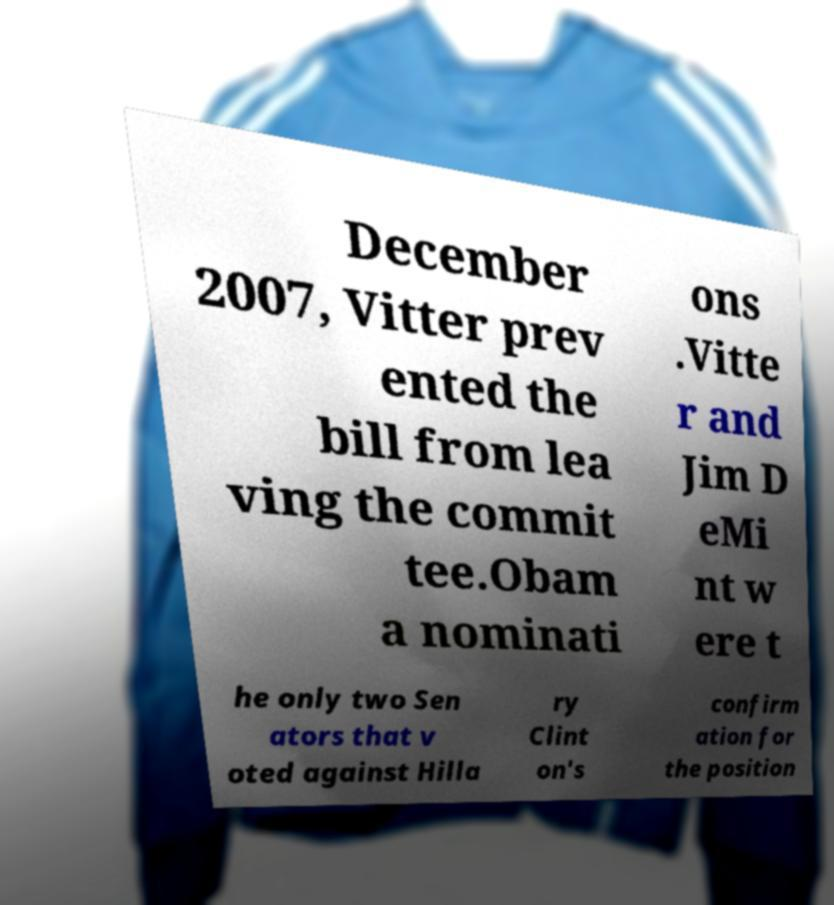Please read and relay the text visible in this image. What does it say? December 2007, Vitter prev ented the bill from lea ving the commit tee.Obam a nominati ons .Vitte r and Jim D eMi nt w ere t he only two Sen ators that v oted against Hilla ry Clint on's confirm ation for the position 